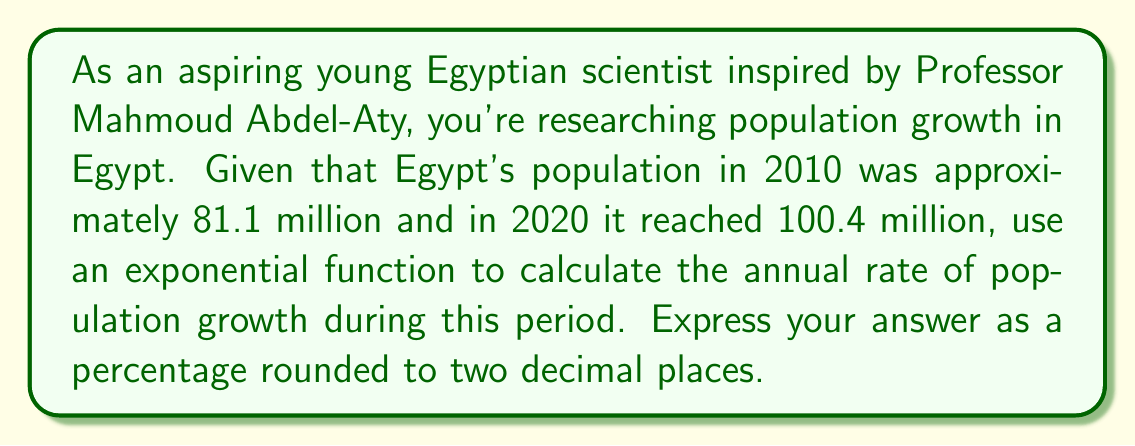Provide a solution to this math problem. Let's approach this step-by-step using the exponential growth formula:

1) The exponential growth formula is:
   $$P(t) = P_0 \cdot e^{rt}$$
   where $P(t)$ is the population at time $t$, $P_0$ is the initial population, $r$ is the growth rate, and $t$ is the time period.

2) We know:
   $P_0 = 81.1$ million (population in 2010)
   $P(10) = 100.4$ million (population in 2020)
   $t = 10$ years

3) Substituting these values into the formula:
   $$100.4 = 81.1 \cdot e^{10r}$$

4) Divide both sides by 81.1:
   $$\frac{100.4}{81.1} = e^{10r}$$

5) Take the natural log of both sides:
   $$\ln(\frac{100.4}{81.1}) = 10r$$

6) Solve for $r$:
   $$r = \frac{\ln(\frac{100.4}{81.1})}{10}$$

7) Calculate:
   $$r = \frac{\ln(1.2381)}{10} = 0.02137$$

8) Convert to a percentage:
   $$r \approx 2.14\%$$

Therefore, the annual rate of population growth in Egypt between 2010 and 2020 was approximately 2.14%.
Answer: 2.14% 